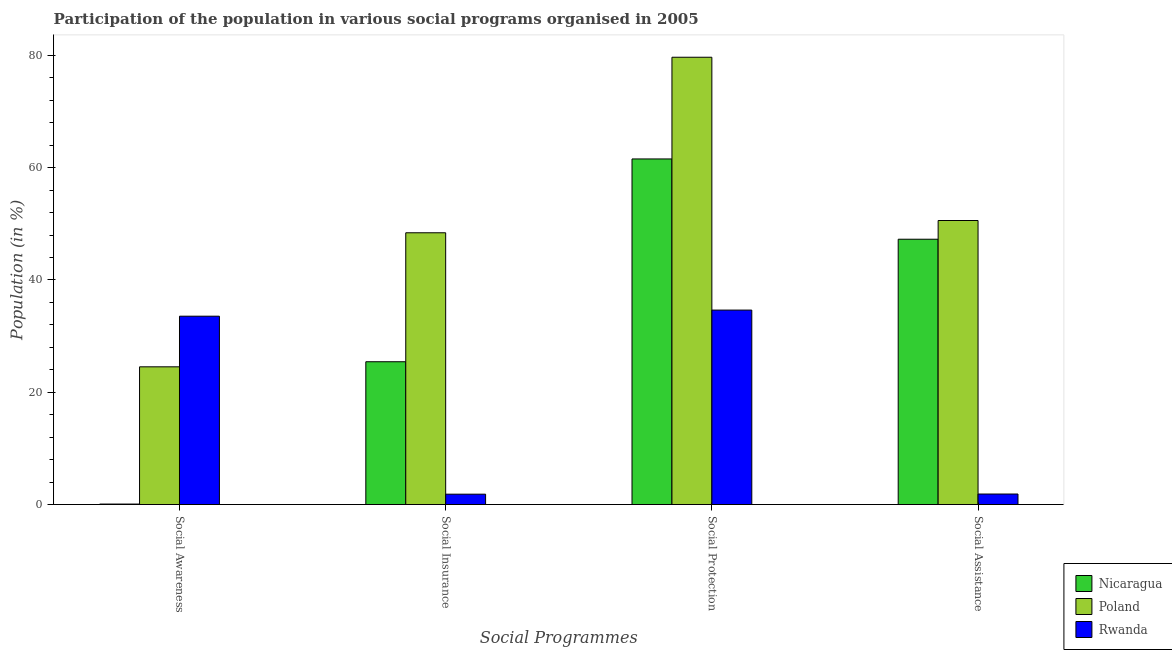How many different coloured bars are there?
Provide a short and direct response. 3. Are the number of bars on each tick of the X-axis equal?
Provide a succinct answer. Yes. How many bars are there on the 3rd tick from the left?
Your answer should be compact. 3. What is the label of the 4th group of bars from the left?
Provide a short and direct response. Social Assistance. What is the participation of population in social protection programs in Rwanda?
Make the answer very short. 34.63. Across all countries, what is the maximum participation of population in social assistance programs?
Keep it short and to the point. 50.58. Across all countries, what is the minimum participation of population in social insurance programs?
Offer a very short reply. 1.85. In which country was the participation of population in social awareness programs maximum?
Keep it short and to the point. Rwanda. In which country was the participation of population in social protection programs minimum?
Your answer should be compact. Rwanda. What is the total participation of population in social awareness programs in the graph?
Ensure brevity in your answer.  58.16. What is the difference between the participation of population in social protection programs in Poland and that in Rwanda?
Ensure brevity in your answer.  45.03. What is the difference between the participation of population in social insurance programs in Rwanda and the participation of population in social awareness programs in Poland?
Your response must be concise. -22.68. What is the average participation of population in social protection programs per country?
Provide a succinct answer. 58.61. What is the difference between the participation of population in social protection programs and participation of population in social insurance programs in Rwanda?
Offer a terse response. 32.78. In how many countries, is the participation of population in social protection programs greater than 60 %?
Offer a terse response. 2. What is the ratio of the participation of population in social insurance programs in Nicaragua to that in Rwanda?
Offer a terse response. 13.77. Is the difference between the participation of population in social protection programs in Nicaragua and Rwanda greater than the difference between the participation of population in social assistance programs in Nicaragua and Rwanda?
Your answer should be very brief. No. What is the difference between the highest and the second highest participation of population in social protection programs?
Keep it short and to the point. 18.11. What is the difference between the highest and the lowest participation of population in social protection programs?
Offer a terse response. 45.03. In how many countries, is the participation of population in social awareness programs greater than the average participation of population in social awareness programs taken over all countries?
Your answer should be very brief. 2. Is the sum of the participation of population in social insurance programs in Nicaragua and Poland greater than the maximum participation of population in social protection programs across all countries?
Provide a succinct answer. No. Is it the case that in every country, the sum of the participation of population in social insurance programs and participation of population in social assistance programs is greater than the sum of participation of population in social awareness programs and participation of population in social protection programs?
Give a very brief answer. No. What does the 3rd bar from the left in Social Awareness represents?
Offer a very short reply. Rwanda. What does the 3rd bar from the right in Social Awareness represents?
Give a very brief answer. Nicaragua. How many bars are there?
Offer a terse response. 12. Are all the bars in the graph horizontal?
Offer a terse response. No. What is the difference between two consecutive major ticks on the Y-axis?
Provide a short and direct response. 20. Are the values on the major ticks of Y-axis written in scientific E-notation?
Your response must be concise. No. Does the graph contain any zero values?
Make the answer very short. No. How many legend labels are there?
Your answer should be compact. 3. How are the legend labels stacked?
Your answer should be very brief. Vertical. What is the title of the graph?
Your response must be concise. Participation of the population in various social programs organised in 2005. What is the label or title of the X-axis?
Your response must be concise. Social Programmes. What is the label or title of the Y-axis?
Keep it short and to the point. Population (in %). What is the Population (in %) in Nicaragua in Social Awareness?
Provide a short and direct response. 0.09. What is the Population (in %) of Poland in Social Awareness?
Ensure brevity in your answer.  24.53. What is the Population (in %) in Rwanda in Social Awareness?
Keep it short and to the point. 33.54. What is the Population (in %) of Nicaragua in Social Insurance?
Your answer should be compact. 25.43. What is the Population (in %) of Poland in Social Insurance?
Provide a succinct answer. 48.4. What is the Population (in %) of Rwanda in Social Insurance?
Give a very brief answer. 1.85. What is the Population (in %) in Nicaragua in Social Protection?
Ensure brevity in your answer.  61.55. What is the Population (in %) of Poland in Social Protection?
Provide a succinct answer. 79.66. What is the Population (in %) in Rwanda in Social Protection?
Give a very brief answer. 34.63. What is the Population (in %) in Nicaragua in Social Assistance?
Your answer should be compact. 47.25. What is the Population (in %) of Poland in Social Assistance?
Provide a succinct answer. 50.58. What is the Population (in %) of Rwanda in Social Assistance?
Offer a very short reply. 1.87. Across all Social Programmes, what is the maximum Population (in %) of Nicaragua?
Provide a succinct answer. 61.55. Across all Social Programmes, what is the maximum Population (in %) in Poland?
Provide a succinct answer. 79.66. Across all Social Programmes, what is the maximum Population (in %) in Rwanda?
Your answer should be very brief. 34.63. Across all Social Programmes, what is the minimum Population (in %) in Nicaragua?
Keep it short and to the point. 0.09. Across all Social Programmes, what is the minimum Population (in %) in Poland?
Offer a terse response. 24.53. Across all Social Programmes, what is the minimum Population (in %) of Rwanda?
Ensure brevity in your answer.  1.85. What is the total Population (in %) in Nicaragua in the graph?
Offer a very short reply. 134.31. What is the total Population (in %) in Poland in the graph?
Your response must be concise. 203.17. What is the total Population (in %) of Rwanda in the graph?
Ensure brevity in your answer.  71.89. What is the difference between the Population (in %) in Nicaragua in Social Awareness and that in Social Insurance?
Offer a terse response. -25.34. What is the difference between the Population (in %) of Poland in Social Awareness and that in Social Insurance?
Keep it short and to the point. -23.87. What is the difference between the Population (in %) of Rwanda in Social Awareness and that in Social Insurance?
Ensure brevity in your answer.  31.7. What is the difference between the Population (in %) of Nicaragua in Social Awareness and that in Social Protection?
Your response must be concise. -61.46. What is the difference between the Population (in %) of Poland in Social Awareness and that in Social Protection?
Your answer should be very brief. -55.13. What is the difference between the Population (in %) of Rwanda in Social Awareness and that in Social Protection?
Your answer should be compact. -1.09. What is the difference between the Population (in %) in Nicaragua in Social Awareness and that in Social Assistance?
Provide a succinct answer. -47.16. What is the difference between the Population (in %) in Poland in Social Awareness and that in Social Assistance?
Your answer should be very brief. -26.06. What is the difference between the Population (in %) of Rwanda in Social Awareness and that in Social Assistance?
Your response must be concise. 31.67. What is the difference between the Population (in %) of Nicaragua in Social Insurance and that in Social Protection?
Offer a terse response. -36.12. What is the difference between the Population (in %) of Poland in Social Insurance and that in Social Protection?
Provide a short and direct response. -31.26. What is the difference between the Population (in %) of Rwanda in Social Insurance and that in Social Protection?
Your response must be concise. -32.78. What is the difference between the Population (in %) in Nicaragua in Social Insurance and that in Social Assistance?
Your response must be concise. -21.82. What is the difference between the Population (in %) in Poland in Social Insurance and that in Social Assistance?
Your response must be concise. -2.18. What is the difference between the Population (in %) in Rwanda in Social Insurance and that in Social Assistance?
Ensure brevity in your answer.  -0.03. What is the difference between the Population (in %) in Nicaragua in Social Protection and that in Social Assistance?
Make the answer very short. 14.3. What is the difference between the Population (in %) of Poland in Social Protection and that in Social Assistance?
Your response must be concise. 29.08. What is the difference between the Population (in %) of Rwanda in Social Protection and that in Social Assistance?
Keep it short and to the point. 32.76. What is the difference between the Population (in %) in Nicaragua in Social Awareness and the Population (in %) in Poland in Social Insurance?
Ensure brevity in your answer.  -48.31. What is the difference between the Population (in %) of Nicaragua in Social Awareness and the Population (in %) of Rwanda in Social Insurance?
Offer a terse response. -1.76. What is the difference between the Population (in %) of Poland in Social Awareness and the Population (in %) of Rwanda in Social Insurance?
Your response must be concise. 22.68. What is the difference between the Population (in %) of Nicaragua in Social Awareness and the Population (in %) of Poland in Social Protection?
Your answer should be very brief. -79.57. What is the difference between the Population (in %) in Nicaragua in Social Awareness and the Population (in %) in Rwanda in Social Protection?
Provide a succinct answer. -34.54. What is the difference between the Population (in %) in Poland in Social Awareness and the Population (in %) in Rwanda in Social Protection?
Provide a short and direct response. -10.1. What is the difference between the Population (in %) in Nicaragua in Social Awareness and the Population (in %) in Poland in Social Assistance?
Make the answer very short. -50.5. What is the difference between the Population (in %) in Nicaragua in Social Awareness and the Population (in %) in Rwanda in Social Assistance?
Give a very brief answer. -1.79. What is the difference between the Population (in %) in Poland in Social Awareness and the Population (in %) in Rwanda in Social Assistance?
Give a very brief answer. 22.65. What is the difference between the Population (in %) in Nicaragua in Social Insurance and the Population (in %) in Poland in Social Protection?
Offer a terse response. -54.23. What is the difference between the Population (in %) of Nicaragua in Social Insurance and the Population (in %) of Rwanda in Social Protection?
Provide a short and direct response. -9.2. What is the difference between the Population (in %) in Poland in Social Insurance and the Population (in %) in Rwanda in Social Protection?
Keep it short and to the point. 13.77. What is the difference between the Population (in %) in Nicaragua in Social Insurance and the Population (in %) in Poland in Social Assistance?
Ensure brevity in your answer.  -25.15. What is the difference between the Population (in %) in Nicaragua in Social Insurance and the Population (in %) in Rwanda in Social Assistance?
Offer a terse response. 23.56. What is the difference between the Population (in %) of Poland in Social Insurance and the Population (in %) of Rwanda in Social Assistance?
Your answer should be very brief. 46.53. What is the difference between the Population (in %) of Nicaragua in Social Protection and the Population (in %) of Poland in Social Assistance?
Offer a very short reply. 10.96. What is the difference between the Population (in %) of Nicaragua in Social Protection and the Population (in %) of Rwanda in Social Assistance?
Offer a very short reply. 59.67. What is the difference between the Population (in %) in Poland in Social Protection and the Population (in %) in Rwanda in Social Assistance?
Offer a terse response. 77.79. What is the average Population (in %) of Nicaragua per Social Programmes?
Ensure brevity in your answer.  33.58. What is the average Population (in %) of Poland per Social Programmes?
Ensure brevity in your answer.  50.79. What is the average Population (in %) of Rwanda per Social Programmes?
Your answer should be very brief. 17.97. What is the difference between the Population (in %) in Nicaragua and Population (in %) in Poland in Social Awareness?
Offer a very short reply. -24.44. What is the difference between the Population (in %) of Nicaragua and Population (in %) of Rwanda in Social Awareness?
Your answer should be compact. -33.46. What is the difference between the Population (in %) of Poland and Population (in %) of Rwanda in Social Awareness?
Your answer should be very brief. -9.02. What is the difference between the Population (in %) of Nicaragua and Population (in %) of Poland in Social Insurance?
Your answer should be compact. -22.97. What is the difference between the Population (in %) in Nicaragua and Population (in %) in Rwanda in Social Insurance?
Your response must be concise. 23.58. What is the difference between the Population (in %) in Poland and Population (in %) in Rwanda in Social Insurance?
Offer a terse response. 46.55. What is the difference between the Population (in %) in Nicaragua and Population (in %) in Poland in Social Protection?
Offer a terse response. -18.11. What is the difference between the Population (in %) in Nicaragua and Population (in %) in Rwanda in Social Protection?
Give a very brief answer. 26.92. What is the difference between the Population (in %) in Poland and Population (in %) in Rwanda in Social Protection?
Provide a short and direct response. 45.03. What is the difference between the Population (in %) of Nicaragua and Population (in %) of Poland in Social Assistance?
Provide a short and direct response. -3.34. What is the difference between the Population (in %) in Nicaragua and Population (in %) in Rwanda in Social Assistance?
Provide a short and direct response. 45.38. What is the difference between the Population (in %) of Poland and Population (in %) of Rwanda in Social Assistance?
Ensure brevity in your answer.  48.71. What is the ratio of the Population (in %) of Nicaragua in Social Awareness to that in Social Insurance?
Provide a short and direct response. 0. What is the ratio of the Population (in %) of Poland in Social Awareness to that in Social Insurance?
Ensure brevity in your answer.  0.51. What is the ratio of the Population (in %) in Rwanda in Social Awareness to that in Social Insurance?
Give a very brief answer. 18.17. What is the ratio of the Population (in %) in Nicaragua in Social Awareness to that in Social Protection?
Ensure brevity in your answer.  0. What is the ratio of the Population (in %) in Poland in Social Awareness to that in Social Protection?
Provide a short and direct response. 0.31. What is the ratio of the Population (in %) of Rwanda in Social Awareness to that in Social Protection?
Give a very brief answer. 0.97. What is the ratio of the Population (in %) of Nicaragua in Social Awareness to that in Social Assistance?
Your answer should be very brief. 0. What is the ratio of the Population (in %) of Poland in Social Awareness to that in Social Assistance?
Make the answer very short. 0.48. What is the ratio of the Population (in %) of Rwanda in Social Awareness to that in Social Assistance?
Provide a short and direct response. 17.91. What is the ratio of the Population (in %) of Nicaragua in Social Insurance to that in Social Protection?
Ensure brevity in your answer.  0.41. What is the ratio of the Population (in %) of Poland in Social Insurance to that in Social Protection?
Offer a terse response. 0.61. What is the ratio of the Population (in %) of Rwanda in Social Insurance to that in Social Protection?
Ensure brevity in your answer.  0.05. What is the ratio of the Population (in %) of Nicaragua in Social Insurance to that in Social Assistance?
Your response must be concise. 0.54. What is the ratio of the Population (in %) in Poland in Social Insurance to that in Social Assistance?
Your answer should be very brief. 0.96. What is the ratio of the Population (in %) of Rwanda in Social Insurance to that in Social Assistance?
Ensure brevity in your answer.  0.99. What is the ratio of the Population (in %) in Nicaragua in Social Protection to that in Social Assistance?
Give a very brief answer. 1.3. What is the ratio of the Population (in %) of Poland in Social Protection to that in Social Assistance?
Keep it short and to the point. 1.57. What is the ratio of the Population (in %) in Rwanda in Social Protection to that in Social Assistance?
Make the answer very short. 18.49. What is the difference between the highest and the second highest Population (in %) of Nicaragua?
Your answer should be compact. 14.3. What is the difference between the highest and the second highest Population (in %) in Poland?
Offer a terse response. 29.08. What is the difference between the highest and the second highest Population (in %) of Rwanda?
Your answer should be compact. 1.09. What is the difference between the highest and the lowest Population (in %) in Nicaragua?
Give a very brief answer. 61.46. What is the difference between the highest and the lowest Population (in %) in Poland?
Your response must be concise. 55.13. What is the difference between the highest and the lowest Population (in %) of Rwanda?
Ensure brevity in your answer.  32.78. 